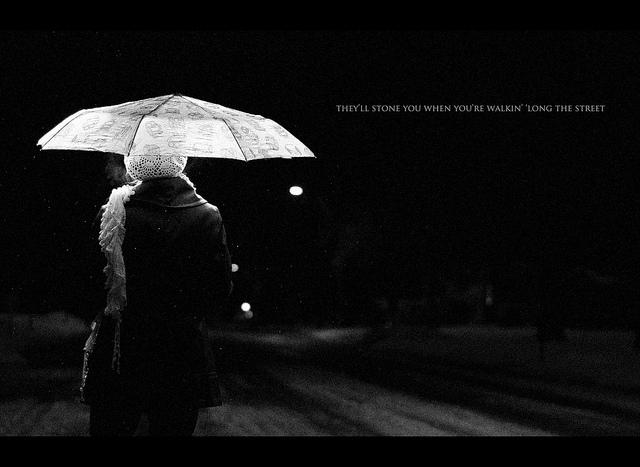Is this a male or female?
Give a very brief answer. Female. What color is this person's hat?
Concise answer only. White. Who said the quote that is written in the background of the picture?
Write a very short answer. Andrew jackson. Is this photo manipulated?
Concise answer only. Yes. 